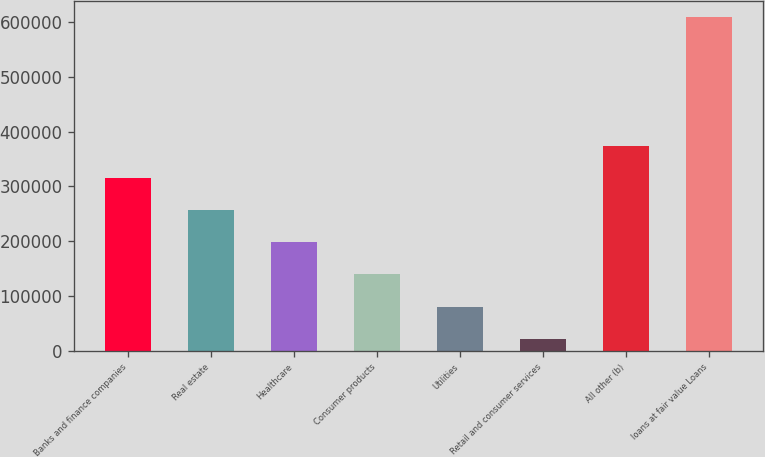<chart> <loc_0><loc_0><loc_500><loc_500><bar_chart><fcel>Banks and finance companies<fcel>Real estate<fcel>Healthcare<fcel>Consumer products<fcel>Utilities<fcel>Retail and consumer services<fcel>All other (b)<fcel>loans at fair value Loans<nl><fcel>315191<fcel>256577<fcel>197963<fcel>139350<fcel>80735.8<fcel>22122<fcel>373805<fcel>608260<nl></chart> 